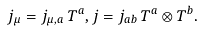<formula> <loc_0><loc_0><loc_500><loc_500>j _ { \mu } = j _ { \mu , a } \, T ^ { a } , j = j _ { a b } \, T ^ { a } \otimes T ^ { b } .</formula> 